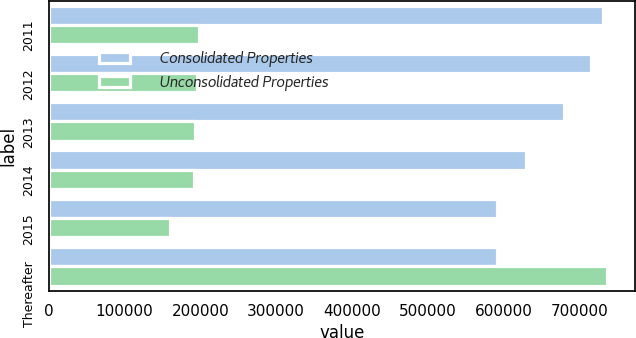<chart> <loc_0><loc_0><loc_500><loc_500><stacked_bar_chart><ecel><fcel>2011<fcel>2012<fcel>2013<fcel>2014<fcel>2015<fcel>Thereafter<nl><fcel>Consolidated Properties<fcel>730702<fcel>715254<fcel>680088<fcel>628922<fcel>591427<fcel>591427<nl><fcel>Unconsolidated Properties<fcel>198861<fcel>196161<fcel>192315<fcel>190958<fcel>160068<fcel>736246<nl></chart> 